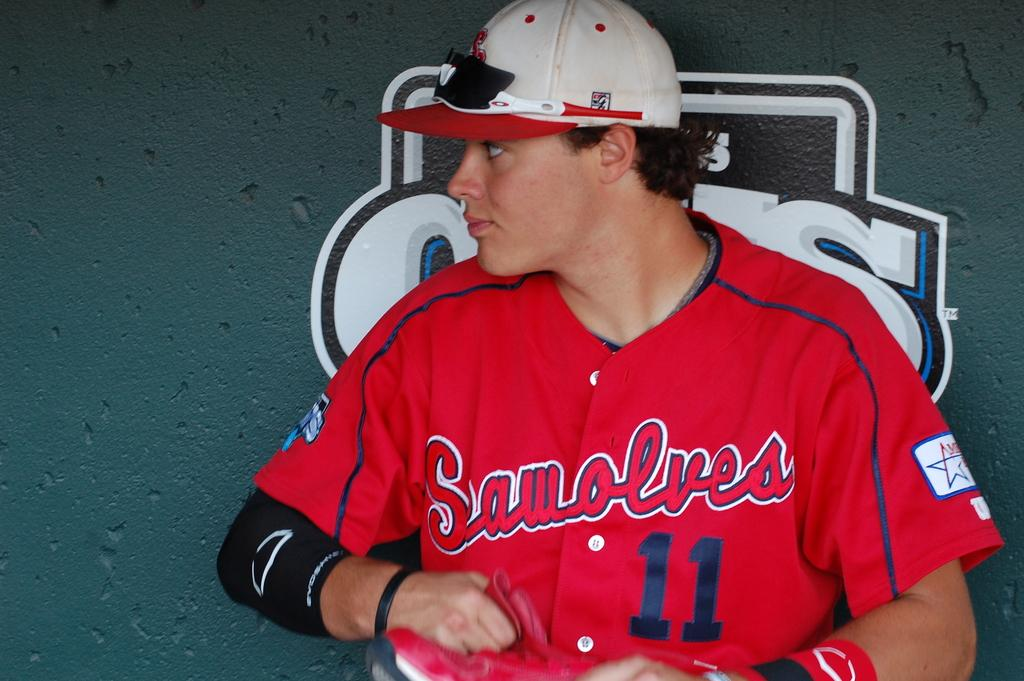<image>
Describe the image concisely. The baseball player is wearing the number 11 